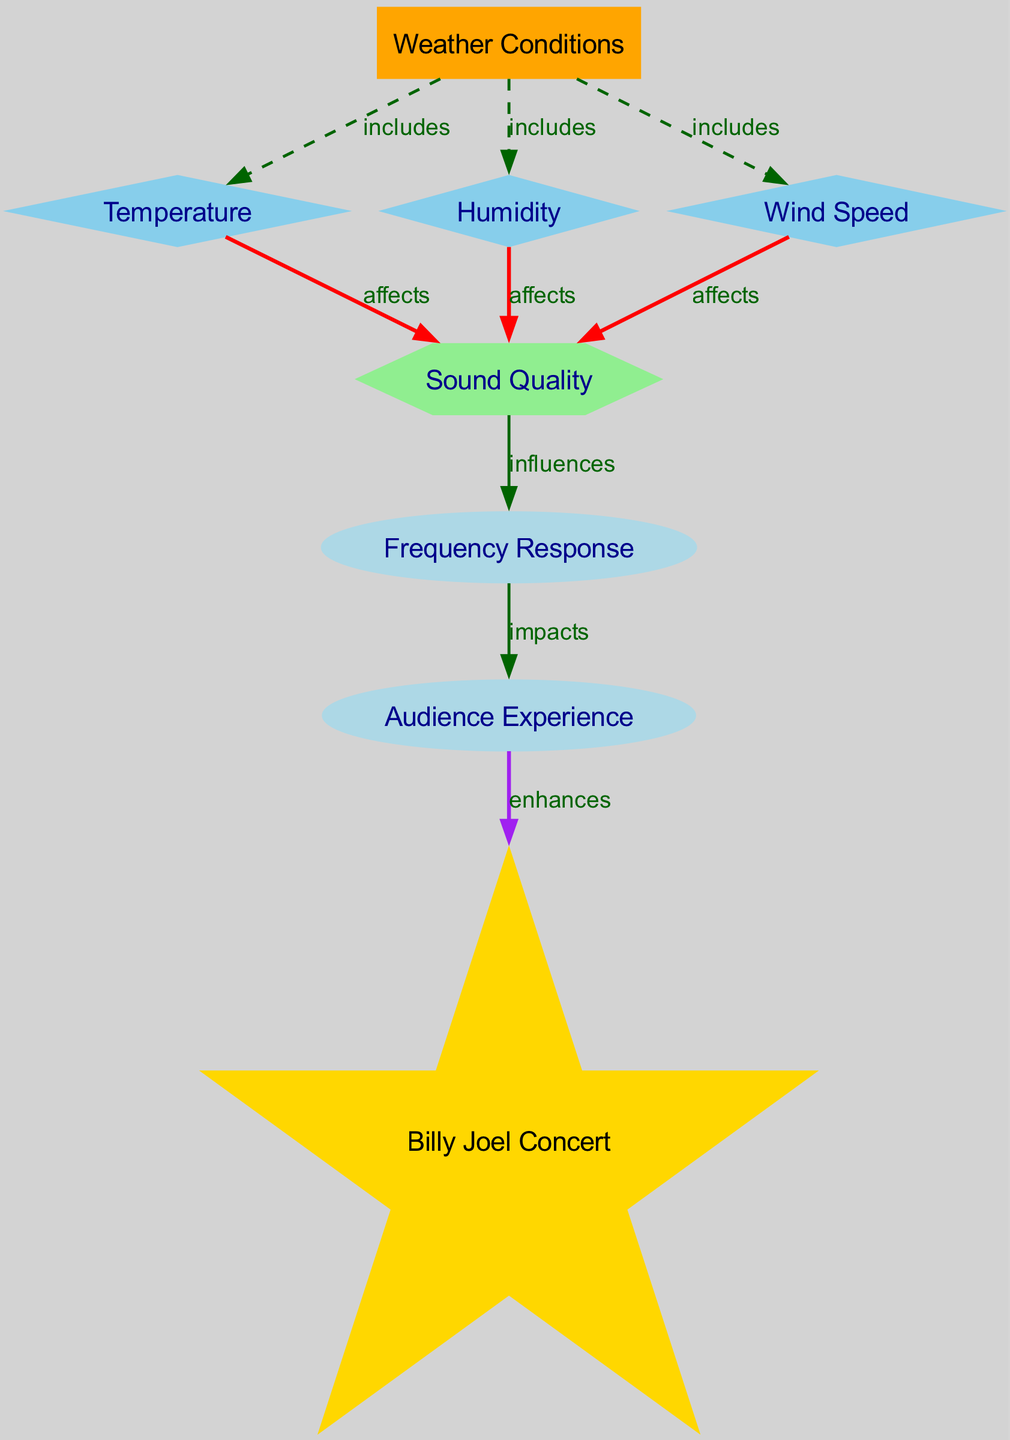What are the three main weather conditions that affect sound quality? The diagram indicates three key weather conditions: Temperature, Humidity, and Wind Speed, all of which are included as factors under the Weather Conditions node.
Answer: Temperature, Humidity, Wind Speed How many nodes are in the diagram? The diagram contains a total of 8 nodes, which include Weather Conditions, Temperature, Humidity, Wind Speed, Sound Quality, Frequency Response, Audience Experience, and Billy Joel Concert.
Answer: 8 What does Humidity affect in the diagram? According to the diagram, Humidity affects Sound Quality, which is illustrated by the direct edge labeled "affects" from Humidity to Sound Quality.
Answer: Sound Quality What node represents the final outcome for the audience? The final outcome for the audience is represented by the node labeled Audience Experience, which concludes the flow from the various influencing nodes.
Answer: Audience Experience How does Sound Quality influence Audience Experience? Sound Quality influences Audience Experience, as indicated by the edge labeled "impacts" connecting Sound Quality to Audience Experience in the diagram.
Answer: impacts What shape is the node that represents Sound Quality? The node representing Sound Quality is shaped like a hexagon, distinguishing it from other nodes with different shapes.
Answer: hexagon Which weather condition has the potential to enhance a Billy Joel Concert according to the diagram? The weather conditions collectively influence Sound Quality, which then impacts the Audience Experience, ultimately enhancing the Billy Joel Concert as shown in the diagram.
Answer: Weather Conditions What color is the node representing Billy Joel Concert? The node representing Billy Joel Concert is colored gold, which differentiates it from other nodes, including rectangles, diamonds, and a hexagon.
Answer: gold What relationship exists between Frequency Response and Audience Experience? The relationship between Frequency Response and Audience Experience is shown with an edge labeled "impacts," which indicates that changes in Frequency Response will impact Audience Experience.
Answer: impacts 